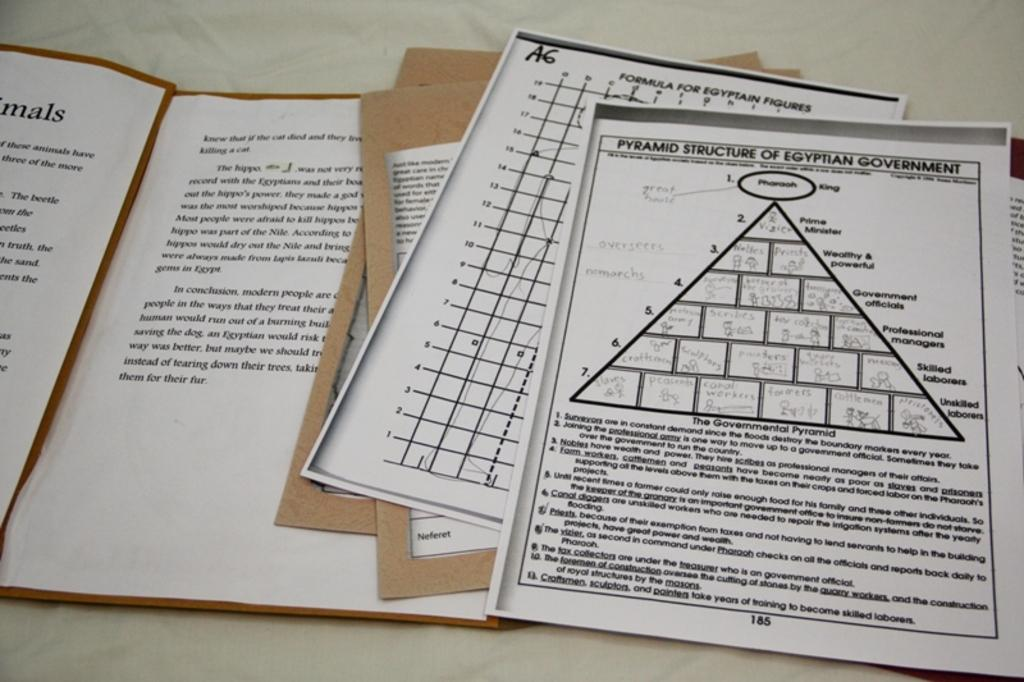<image>
Describe the image concisely. The document explains the structure of the Egyptian government. 